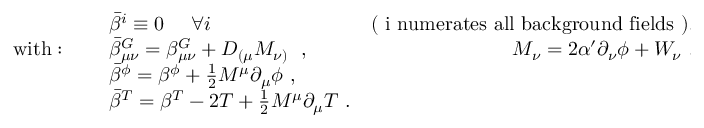Convert formula to latex. <formula><loc_0><loc_0><loc_500><loc_500>\begin{array} { l l r & { { \bar { \beta } ^ { i } \equiv 0 \quad \forall i \ \ } } & { ( i n u m e r a t e s a l l b a c k g r o u n d f i e l d s ) , } \\ { w i t h \colon \quad } & { { \bar { \beta } _ { \mu \nu } ^ { G } = \beta _ { \mu \nu } ^ { G } + D _ { ( \mu } M _ { \nu ) } \ \ , \ \ } } & { { M _ { \nu } = 2 \alpha ^ { \prime } \partial _ { \nu } \phi + W _ { \nu } \ , } } & { { \bar { \beta } ^ { \phi } = \beta ^ { \phi } + \frac { 1 } { 2 } M ^ { \mu } \partial _ { \mu } \phi \ , } } & { { \bar { \beta } ^ { T } = \beta ^ { T } - 2 T + \frac { 1 } { 2 } M ^ { \mu } \partial _ { \mu } T \ . } } \end{array}</formula> 